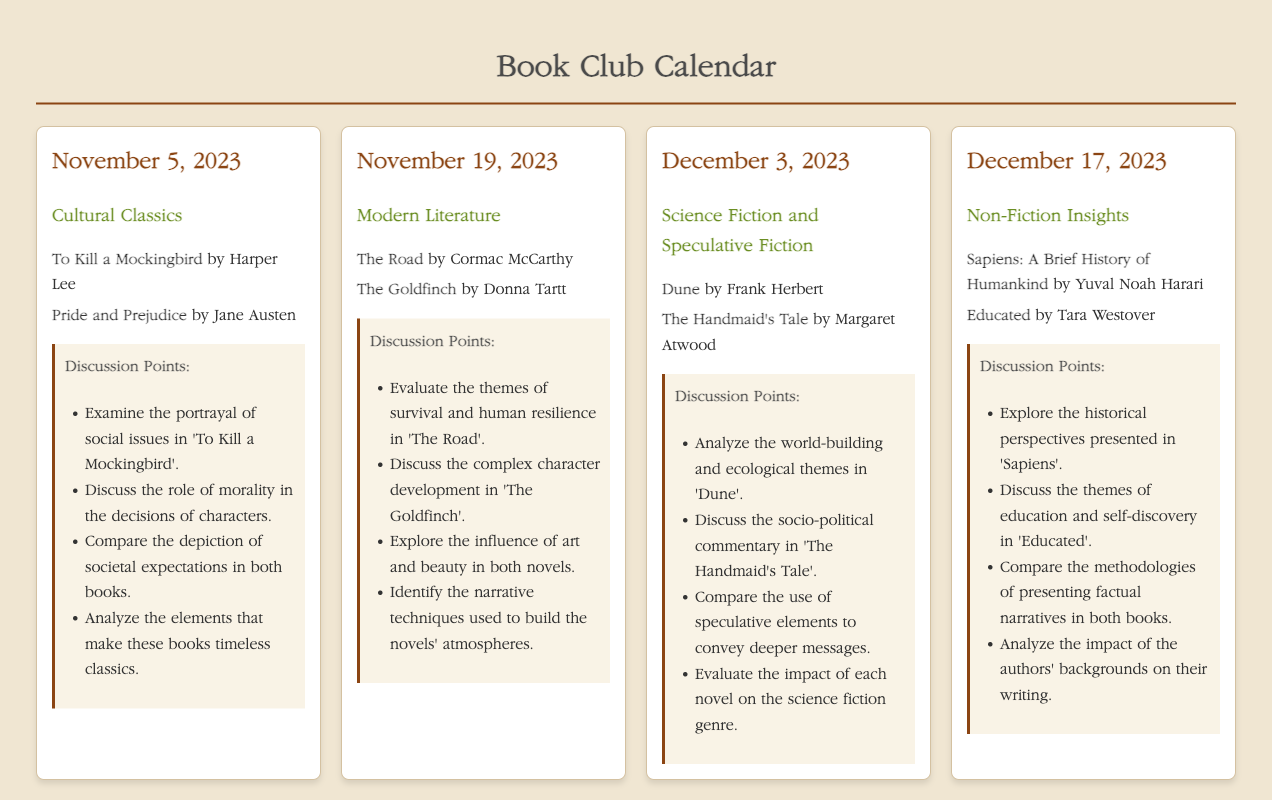What is the date of the first meeting? The date of the first meeting is stated in the document as November 5, 2023.
Answer: November 5, 2023 How many books are included in the reading list for the meeting on December 3, 2023? The reading list for the meeting on December 3, 2023 includes two books.
Answer: 2 What are the titles of the books for the "Cultural Classics" meeting? The titles of the books listed for the "Cultural Classics" meeting are found in the reading list: "To Kill a Mockingbird" and "Pride and Prejudice".
Answer: To Kill a Mockingbird, Pride and Prejudice Which topic is discussed in the meeting scheduled for December 17, 2023? The topic for the meeting scheduled on December 17, 2023 is mentioned in the meeting section as "Non-Fiction Insights".
Answer: Non-Fiction Insights What is one discussion point for the "Modern Literature" meeting? One of the discussion points for the "Modern Literature" meeting is listed in the document: "Discuss the complex character development in 'The Goldfinch'."
Answer: Discuss the complex character development in 'The Goldfinch' 